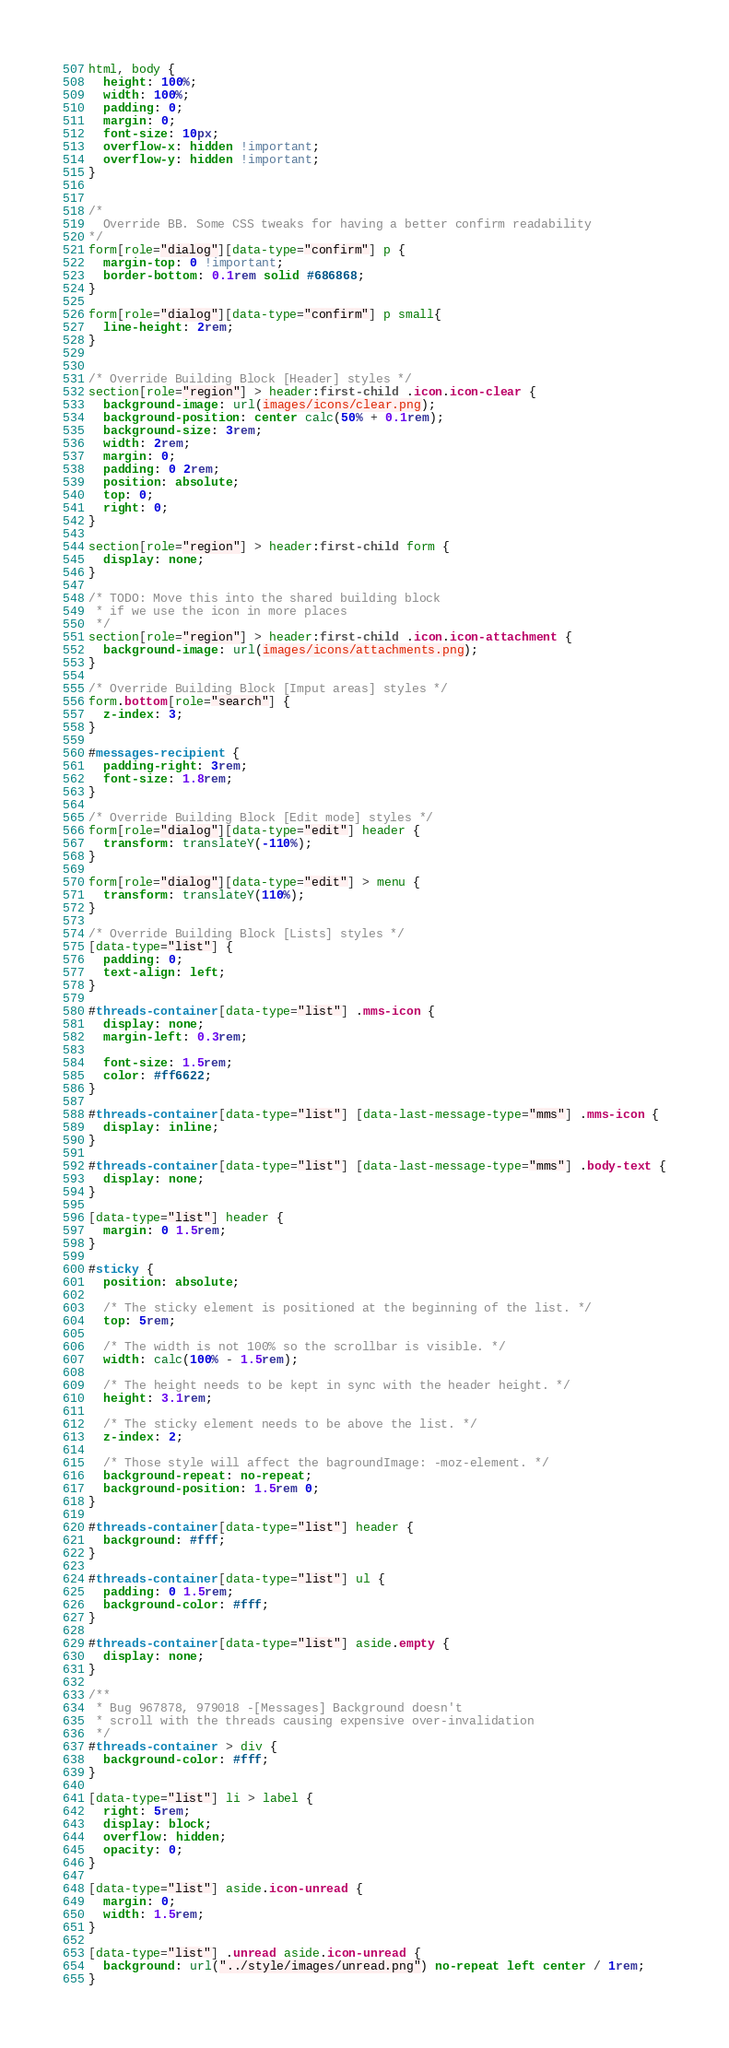Convert code to text. <code><loc_0><loc_0><loc_500><loc_500><_CSS_>html, body {
  height: 100%;
  width: 100%;
  padding: 0;
  margin: 0;
  font-size: 10px;
  overflow-x: hidden !important;
  overflow-y: hidden !important;
}


/*
  Override BB. Some CSS tweaks for having a better confirm readability
*/
form[role="dialog"][data-type="confirm"] p {
  margin-top: 0 !important;
  border-bottom: 0.1rem solid #686868;
}

form[role="dialog"][data-type="confirm"] p small{
  line-height: 2rem;
}


/* Override Building Block [Header] styles */
section[role="region"] > header:first-child .icon.icon-clear {
  background-image: url(images/icons/clear.png);
  background-position: center calc(50% + 0.1rem);
  background-size: 3rem;
  width: 2rem;
  margin: 0;
  padding: 0 2rem;
  position: absolute;
  top: 0;
  right: 0;
}

section[role="region"] > header:first-child form {
  display: none;
}

/* TODO: Move this into the shared building block
 * if we use the icon in more places
 */
section[role="region"] > header:first-child .icon.icon-attachment {
  background-image: url(images/icons/attachments.png);
}

/* Override Building Block [Imput areas] styles */
form.bottom[role="search"] {
  z-index: 3;
}

#messages-recipient {
  padding-right: 3rem;
  font-size: 1.8rem;
}

/* Override Building Block [Edit mode] styles */
form[role="dialog"][data-type="edit"] header {
  transform: translateY(-110%);
}

form[role="dialog"][data-type="edit"] > menu {
  transform: translateY(110%);
}

/* Override Building Block [Lists] styles */
[data-type="list"] {
  padding: 0;
  text-align: left;
}

#threads-container[data-type="list"] .mms-icon {
  display: none;
  margin-left: 0.3rem;

  font-size: 1.5rem;
  color: #ff6622;
}

#threads-container[data-type="list"] [data-last-message-type="mms"] .mms-icon {
  display: inline;
}

#threads-container[data-type="list"] [data-last-message-type="mms"] .body-text {
  display: none;
}

[data-type="list"] header {
  margin: 0 1.5rem;
}

#sticky {
  position: absolute;

  /* The sticky element is positioned at the beginning of the list. */
  top: 5rem;

  /* The width is not 100% so the scrollbar is visible. */
  width: calc(100% - 1.5rem);

  /* The height needs to be kept in sync with the header height. */
  height: 3.1rem;

  /* The sticky element needs to be above the list. */
  z-index: 2;

  /* Those style will affect the bagroundImage: -moz-element. */
  background-repeat: no-repeat;
  background-position: 1.5rem 0;
}

#threads-container[data-type="list"] header {
  background: #fff;
}

#threads-container[data-type="list"] ul {
  padding: 0 1.5rem;
  background-color: #fff;
}

#threads-container[data-type="list"] aside.empty {
  display: none;
}

/**
 * Bug 967878, 979018 -[Messages] Background doesn't
 * scroll with the threads causing expensive over-invalidation
 */
#threads-container > div {
  background-color: #fff;
}

[data-type="list"] li > label {
  right: 5rem;
  display: block;
  overflow: hidden;
  opacity: 0;
}

[data-type="list"] aside.icon-unread {
  margin: 0;
  width: 1.5rem;
}

[data-type="list"] .unread aside.icon-unread {
  background: url("../style/images/unread.png") no-repeat left center / 1rem;
}
</code> 